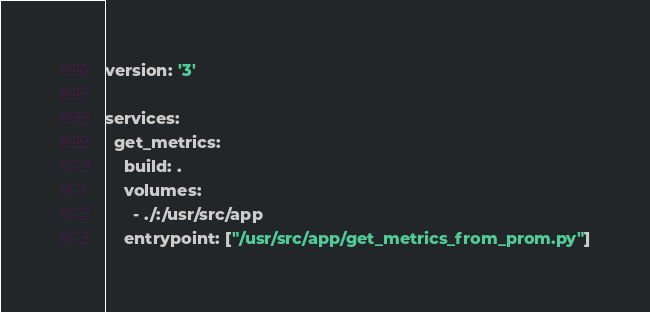Convert code to text. <code><loc_0><loc_0><loc_500><loc_500><_YAML_>version: '3'

services:
  get_metrics:
    build: .
    volumes:
      - ./:/usr/src/app
    entrypoint: ["/usr/src/app/get_metrics_from_prom.py"]
</code> 